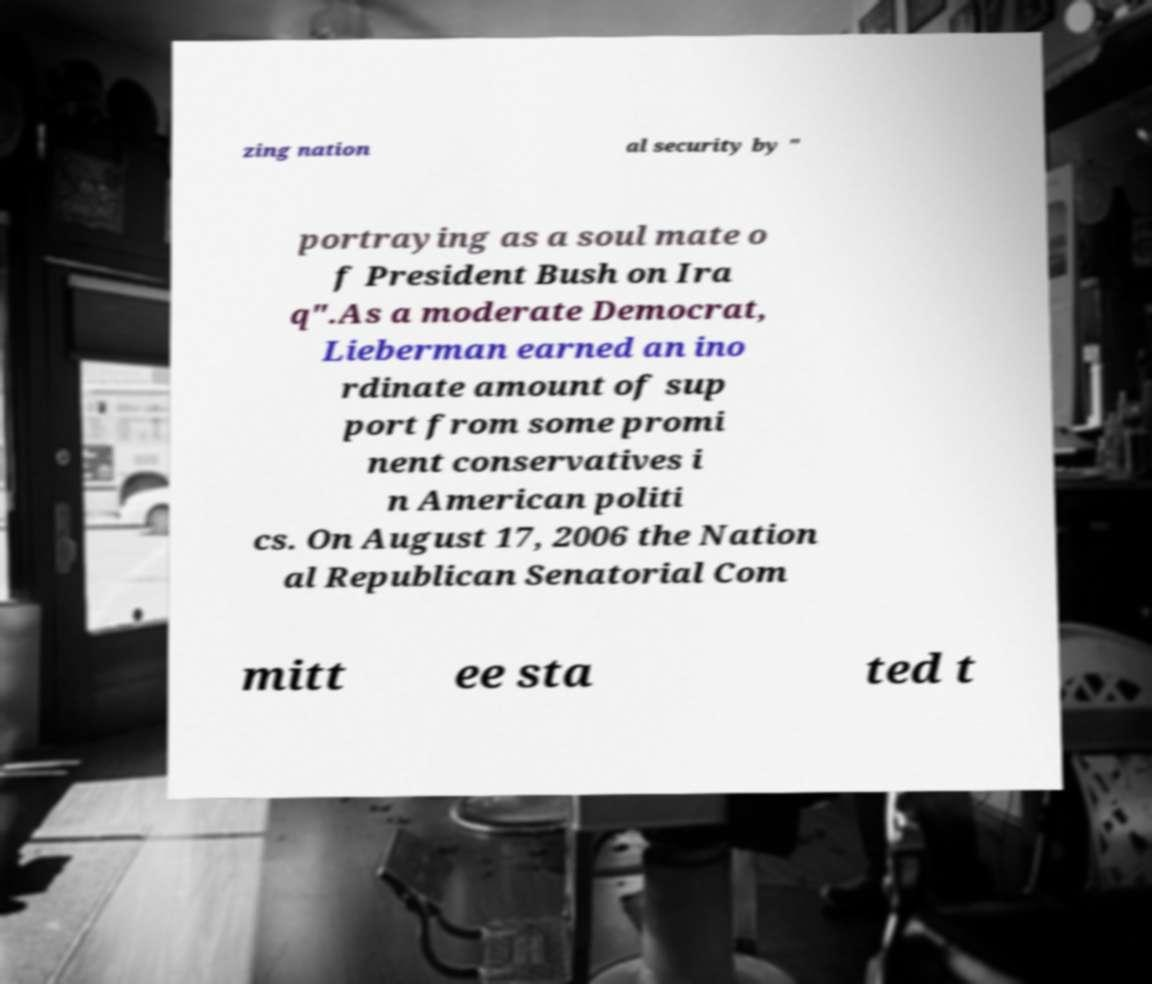Please identify and transcribe the text found in this image. zing nation al security by " portraying as a soul mate o f President Bush on Ira q".As a moderate Democrat, Lieberman earned an ino rdinate amount of sup port from some promi nent conservatives i n American politi cs. On August 17, 2006 the Nation al Republican Senatorial Com mitt ee sta ted t 